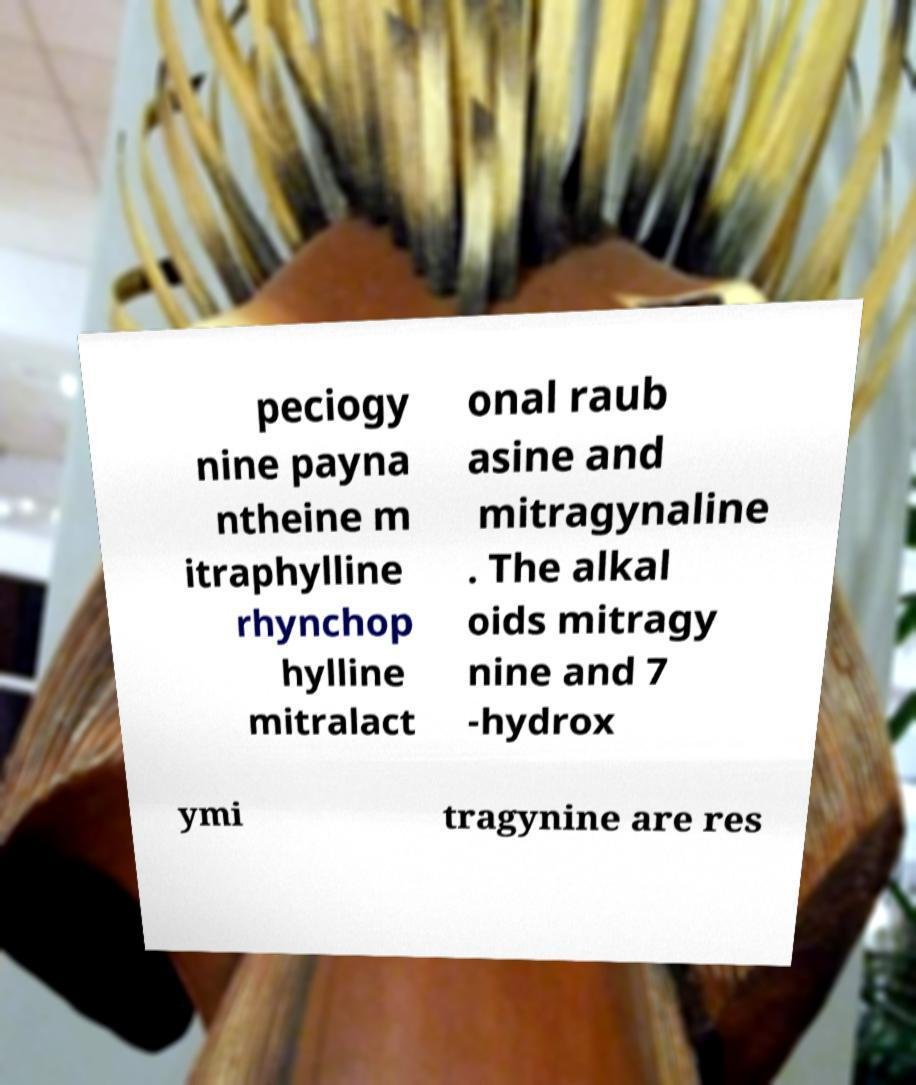I need the written content from this picture converted into text. Can you do that? peciogy nine payna ntheine m itraphylline rhynchop hylline mitralact onal raub asine and mitragynaline . The alkal oids mitragy nine and 7 -hydrox ymi tragynine are res 